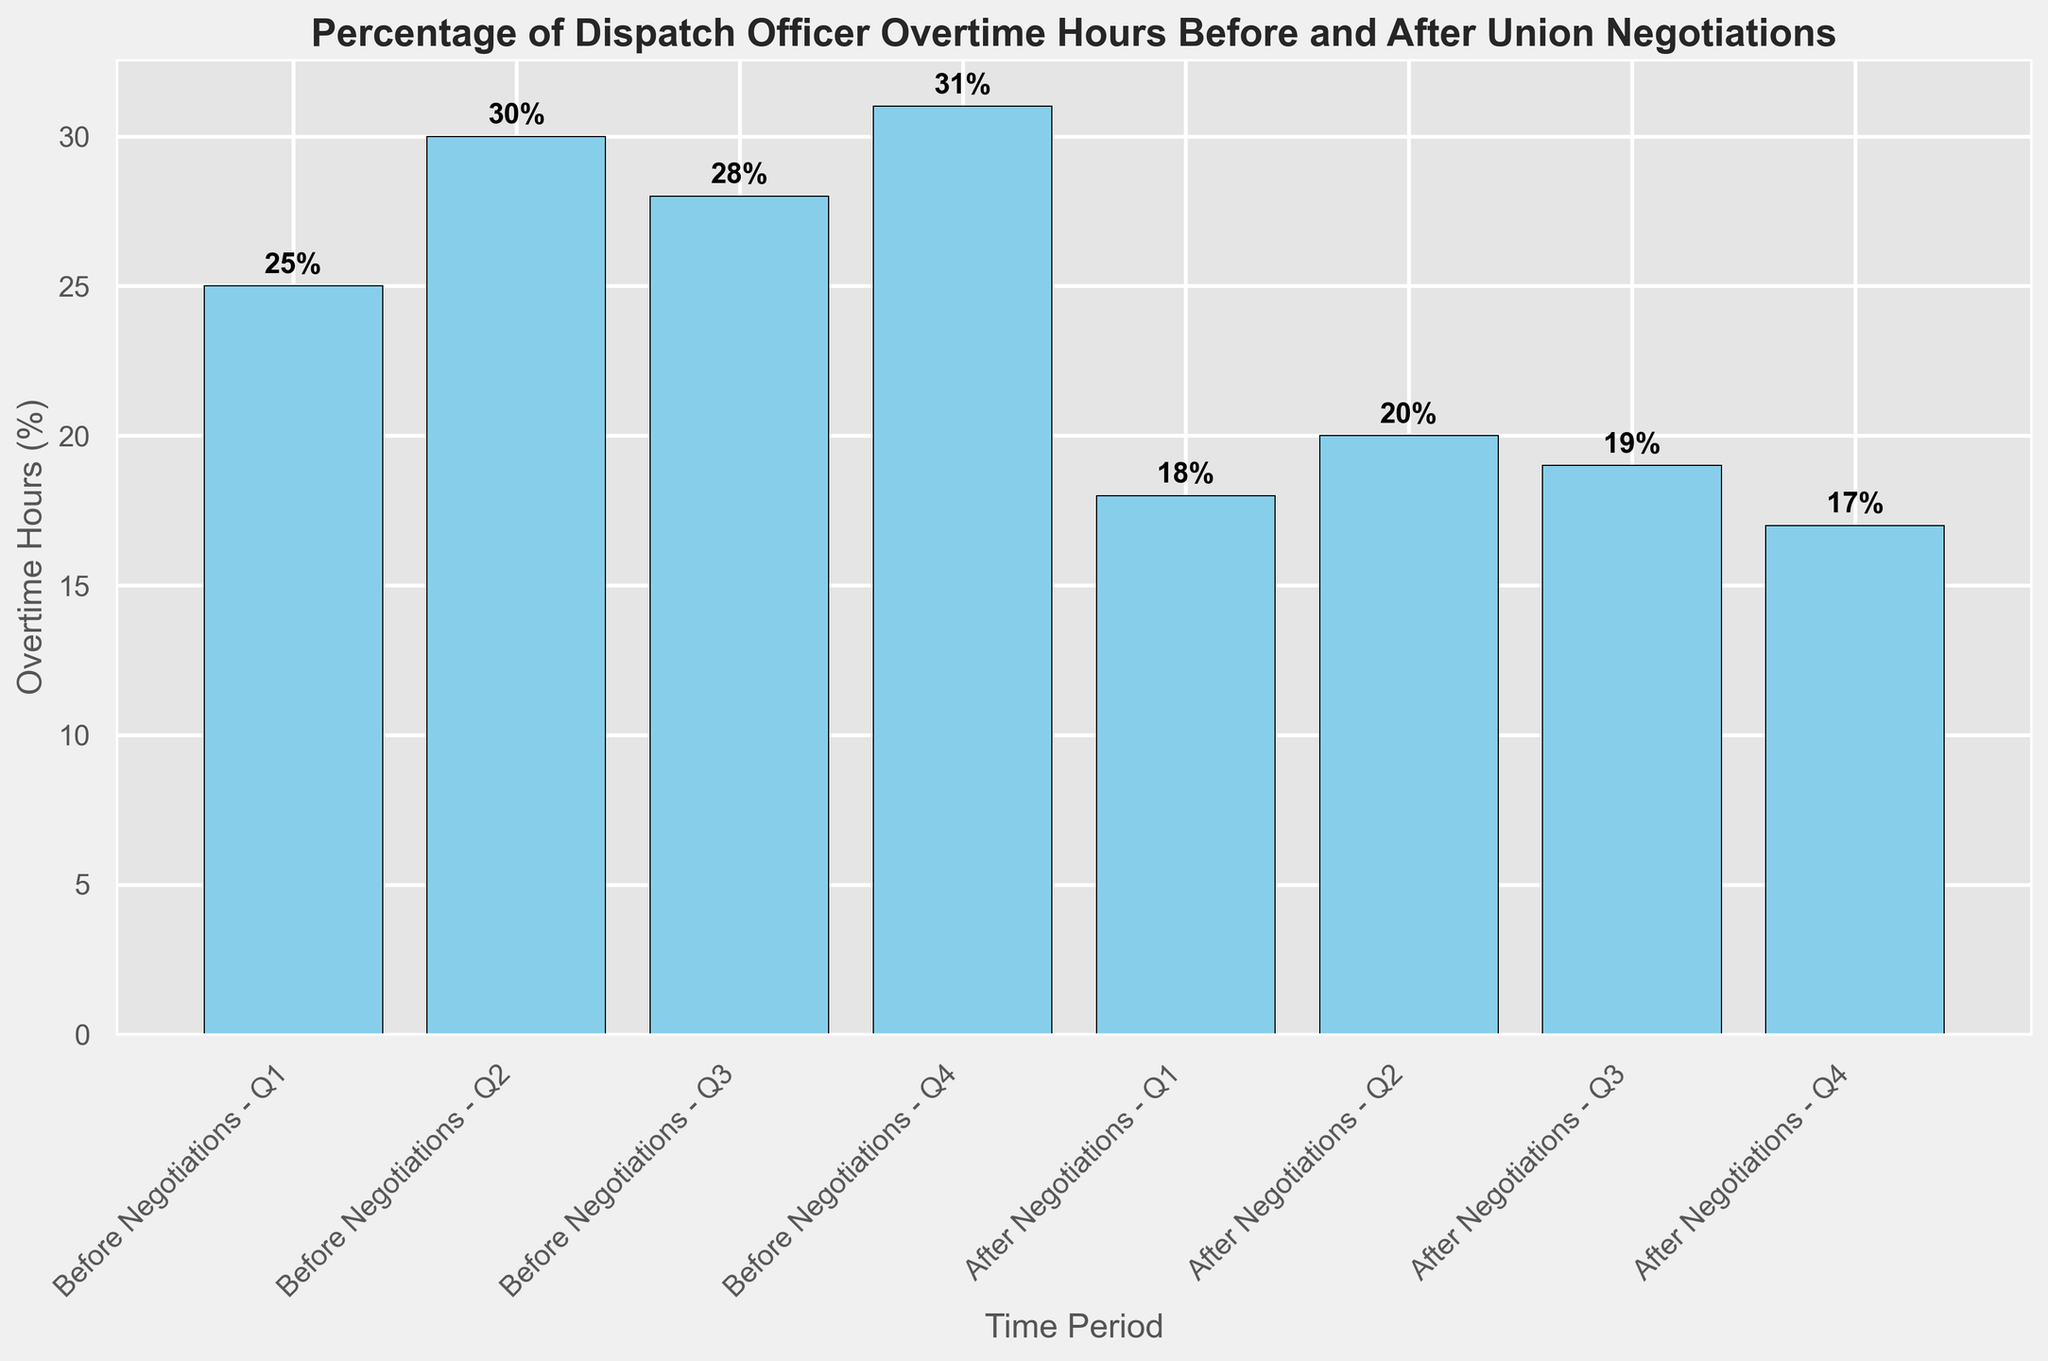What is the percentage of overtime hours in Q2 after the union negotiations? The bar representing "After Negotiations - Q2" shows a height of 20%, which indicates that the percentage of overtime hours is 20%.
Answer: 20% What is the difference in the percentage of overtime hours before and after negotiations for Q4? The percentage of overtime hours before negotiations in Q4 is 31%, while after negotiations in Q4 it is 17%. So, the difference is 31% - 17% = 14%.
Answer: 14% Which quarter saw the highest percentage of overtime hours before negotiations? By comparing the heights of the bars before negotiations, "Before Negotiations - Q4" has the highest percentage at 31%.
Answer: Q4 How much did the overtime hours percentage reduce on average after the negotiations? The average overtime hours percentage before negotiations is (25% + 30% + 28% + 31%) / 4 = 28.5%, and after negotiations is (18% + 20% + 19% + 17%) / 4 = 18.5%. The reduction is 28.5% - 18.5% = 10%.
Answer: 10% In which quarter did the overtime hours percentage remain closest to the average percentage after negotiations? The average percentage of overtime hours after negotiations is (18% + 20% + 19% + 17%) / 4 = 18.5%. "After Negotiations - Q1" and "After Negotiations - Q3" are closest with 18% and 19%, respectively, where 18.5% - 18% = 0.5% and 19% - 18.5% = 0.5%. Both quarters are equally close.
Answer: Q1 and Q3 Was there any quarter in which the percentage of overtime hours was equal before and after negotiations? None of the bars for "Before Negotiations" has the same height as any of the bars for "After Negotiations".
Answer: No Compare the percentage reduction from Q1 to Q4 after negotiations. Which quarter experienced the greatest decrease? For Q1, the reduction is 25% - 18% = 7%. For Q2, the reduction is 30% - 20% = 10%. For Q3, the reduction is 28% - 19% = 9%. For Q4, the reduction is 31% - 17% = 14%. Q4 experienced the greatest decrease with a reduction of 14%.
Answer: Q4 Which quarter after negotiations had the lowest percentage of overtime hours? Looking at the bars after negotiations, "After Negotiations - Q4" has the lowest percentage at 17%.
Answer: Q4 How does the height of the bar for Q3 before negotiations compare to the height of the bar for Q3 after negotiations? The bar for "Before Negotiations - Q3" has a height of 28%, while the bar for "After Negotiations - Q3" stands at 19%. Therefore, the bar before negotiations is taller by 28% - 19% = 9%.
Answer: Taller by 9% What is the overall reduction in the total percentage of overtime hours from before to after negotiations across all quarters combined? The total percentage before negotiations is 25% + 30% + 28% + 31% = 114%, and after negotiations is 18% + 20% + 19% + 17% = 74%. The overall reduction is 114% - 74% = 40%.
Answer: 40% 